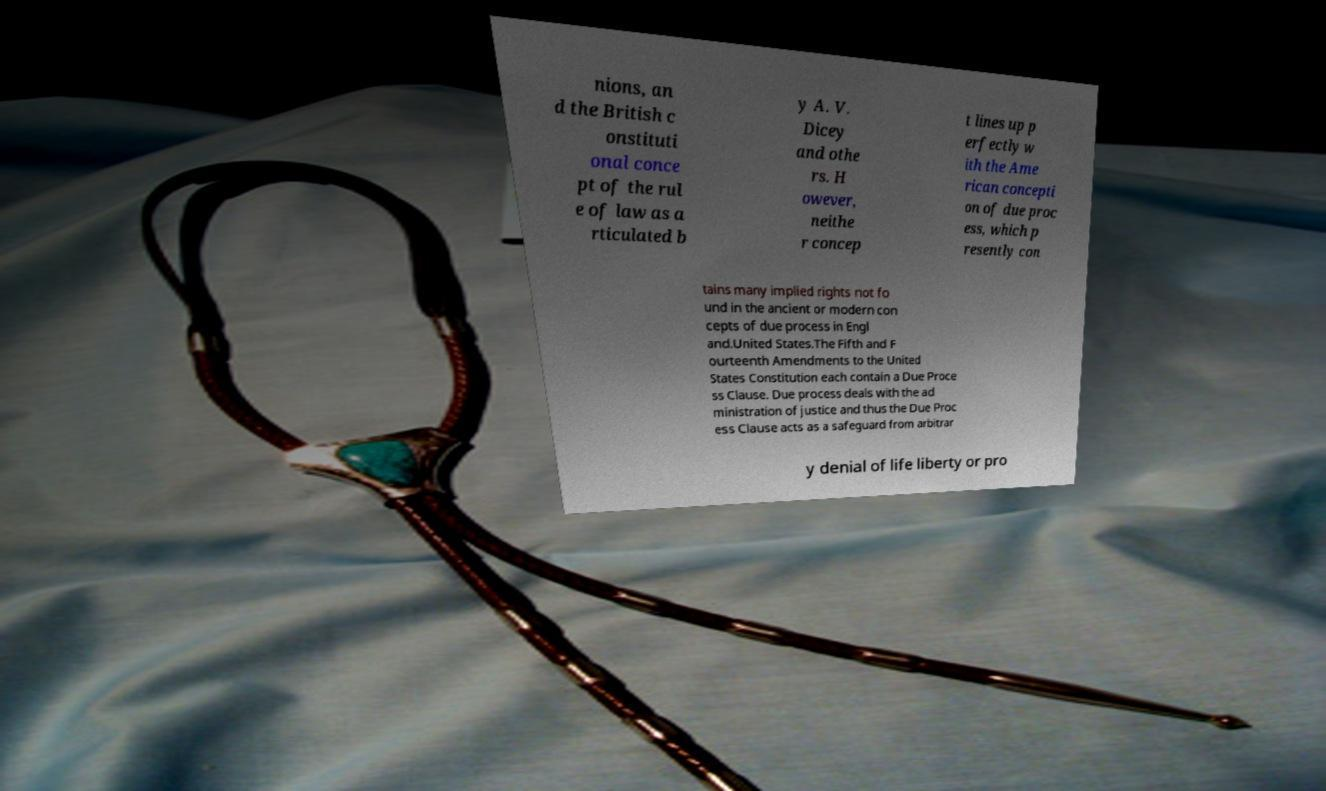I need the written content from this picture converted into text. Can you do that? nions, an d the British c onstituti onal conce pt of the rul e of law as a rticulated b y A. V. Dicey and othe rs. H owever, neithe r concep t lines up p erfectly w ith the Ame rican concepti on of due proc ess, which p resently con tains many implied rights not fo und in the ancient or modern con cepts of due process in Engl and.United States.The Fifth and F ourteenth Amendments to the United States Constitution each contain a Due Proce ss Clause. Due process deals with the ad ministration of justice and thus the Due Proc ess Clause acts as a safeguard from arbitrar y denial of life liberty or pro 